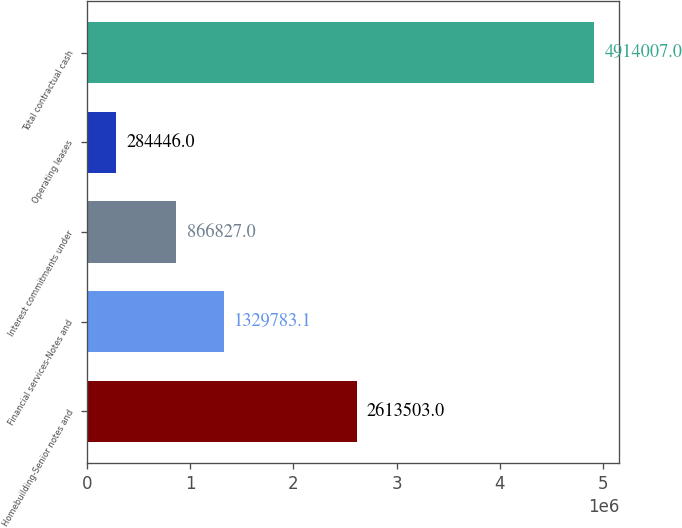Convert chart. <chart><loc_0><loc_0><loc_500><loc_500><bar_chart><fcel>Homebuilding-Senior notes and<fcel>Financial services-Notes and<fcel>Interest commitments under<fcel>Operating leases<fcel>Total contractual cash<nl><fcel>2.6135e+06<fcel>1.32978e+06<fcel>866827<fcel>284446<fcel>4.91401e+06<nl></chart> 